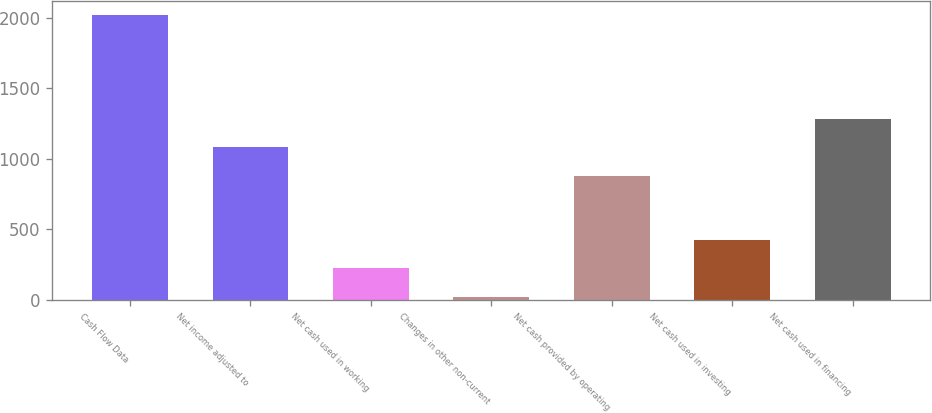Convert chart. <chart><loc_0><loc_0><loc_500><loc_500><bar_chart><fcel>Cash Flow Data<fcel>Net income adjusted to<fcel>Net cash used in working<fcel>Changes in other non-current<fcel>Net cash provided by operating<fcel>Net cash used in investing<fcel>Net cash used in financing<nl><fcel>2017<fcel>1081.06<fcel>223.66<fcel>24.4<fcel>881.8<fcel>422.92<fcel>1280.32<nl></chart> 